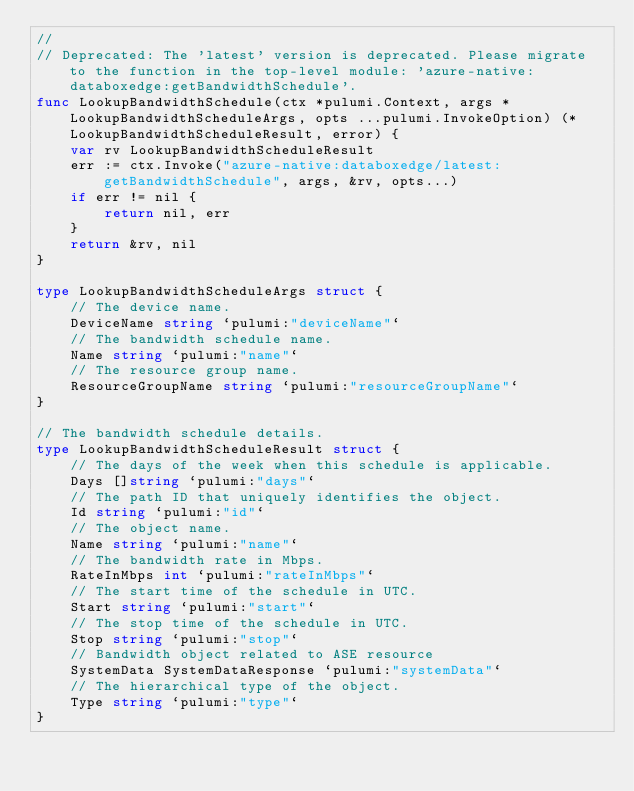<code> <loc_0><loc_0><loc_500><loc_500><_Go_>//
// Deprecated: The 'latest' version is deprecated. Please migrate to the function in the top-level module: 'azure-native:databoxedge:getBandwidthSchedule'.
func LookupBandwidthSchedule(ctx *pulumi.Context, args *LookupBandwidthScheduleArgs, opts ...pulumi.InvokeOption) (*LookupBandwidthScheduleResult, error) {
	var rv LookupBandwidthScheduleResult
	err := ctx.Invoke("azure-native:databoxedge/latest:getBandwidthSchedule", args, &rv, opts...)
	if err != nil {
		return nil, err
	}
	return &rv, nil
}

type LookupBandwidthScheduleArgs struct {
	// The device name.
	DeviceName string `pulumi:"deviceName"`
	// The bandwidth schedule name.
	Name string `pulumi:"name"`
	// The resource group name.
	ResourceGroupName string `pulumi:"resourceGroupName"`
}

// The bandwidth schedule details.
type LookupBandwidthScheduleResult struct {
	// The days of the week when this schedule is applicable.
	Days []string `pulumi:"days"`
	// The path ID that uniquely identifies the object.
	Id string `pulumi:"id"`
	// The object name.
	Name string `pulumi:"name"`
	// The bandwidth rate in Mbps.
	RateInMbps int `pulumi:"rateInMbps"`
	// The start time of the schedule in UTC.
	Start string `pulumi:"start"`
	// The stop time of the schedule in UTC.
	Stop string `pulumi:"stop"`
	// Bandwidth object related to ASE resource
	SystemData SystemDataResponse `pulumi:"systemData"`
	// The hierarchical type of the object.
	Type string `pulumi:"type"`
}
</code> 